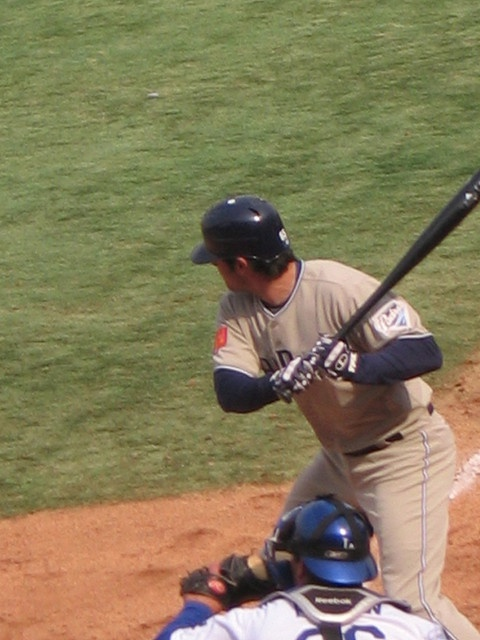Describe the objects in this image and their specific colors. I can see people in olive, tan, black, gray, and maroon tones, people in olive, lavender, black, gray, and maroon tones, baseball glove in olive, black, maroon, and brown tones, and baseball bat in olive, black, and gray tones in this image. 